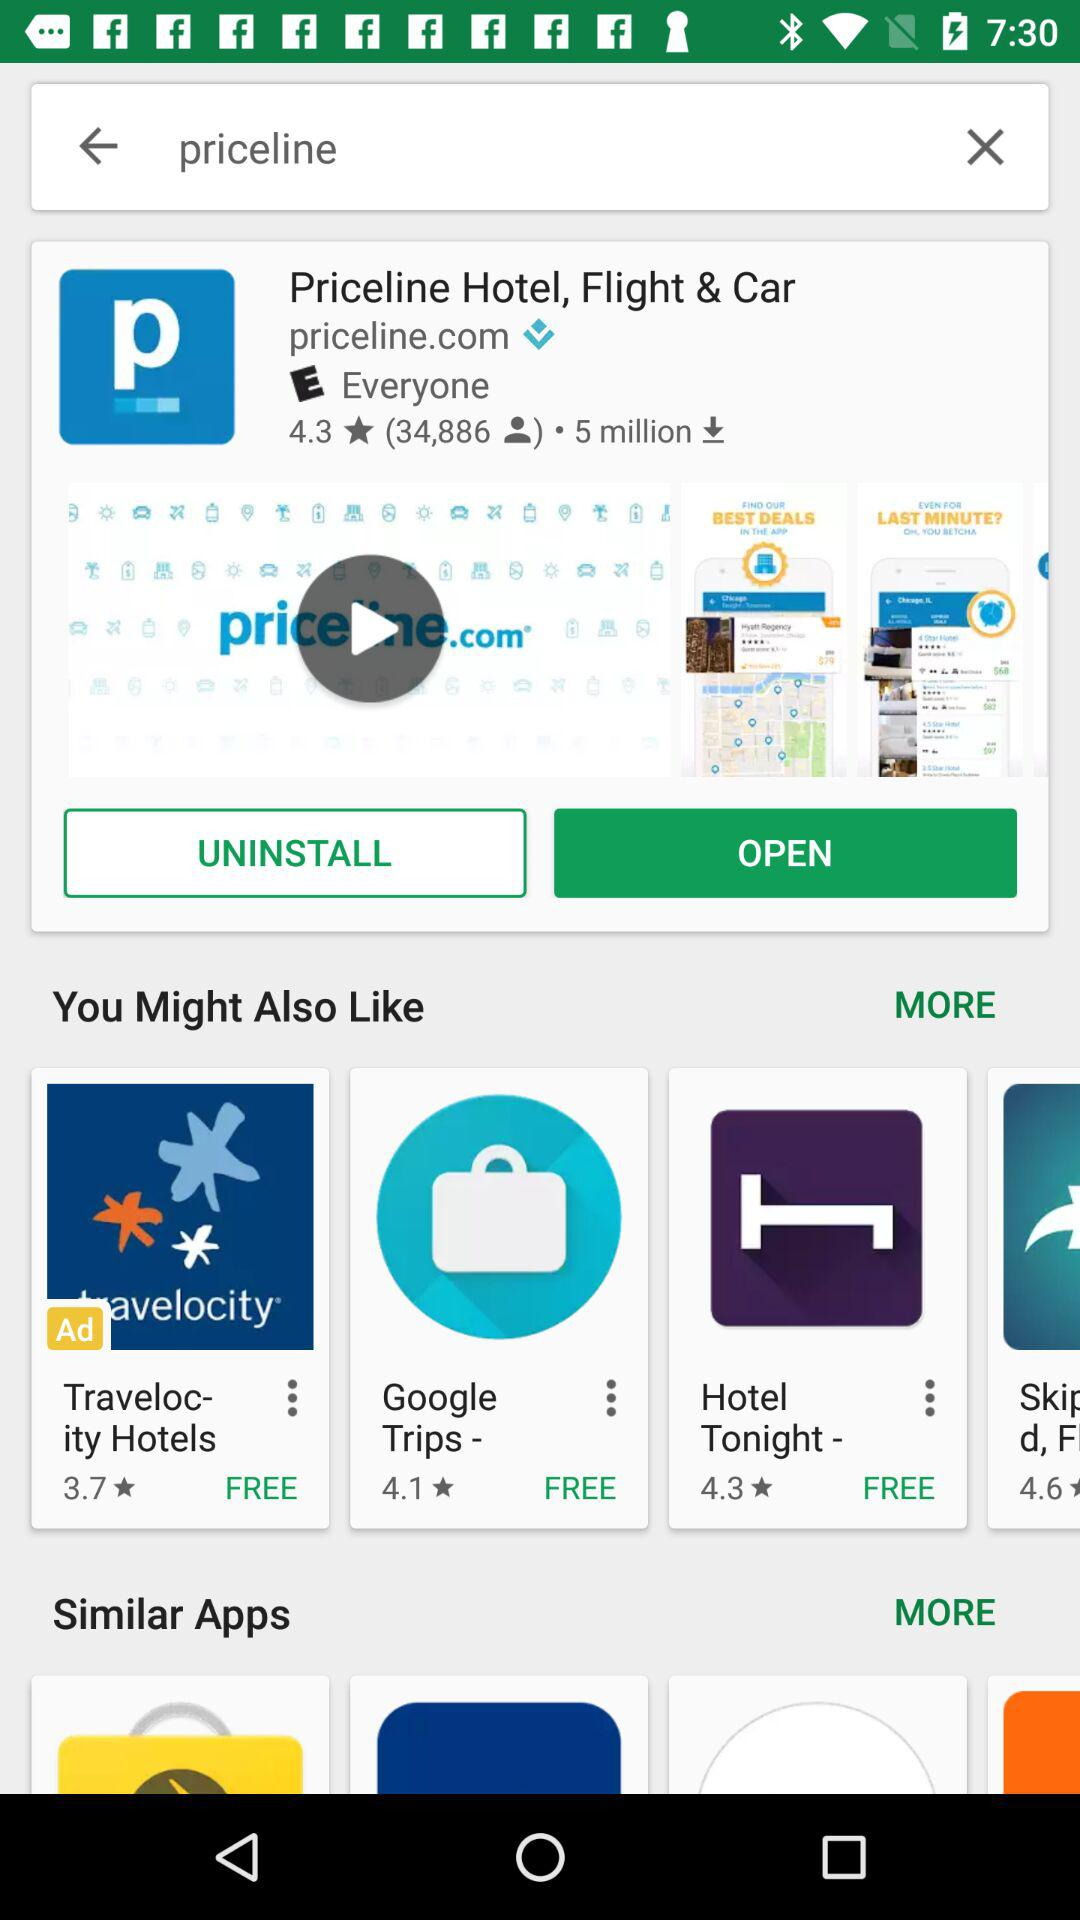What's the URL?
When the provided information is insufficient, respond with <no answer>. <no answer> 